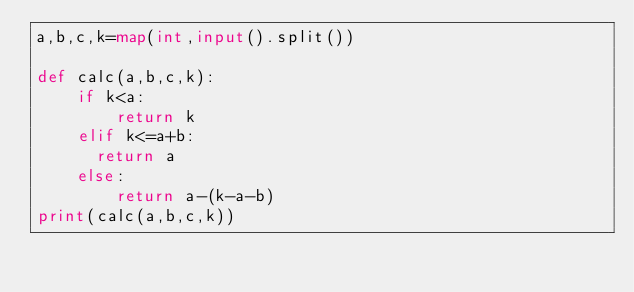Convert code to text. <code><loc_0><loc_0><loc_500><loc_500><_Python_>a,b,c,k=map(int,input().split())
 
def calc(a,b,c,k):
    if k<a:
        return k
    elif k<=a+b:
      return a
    else:
        return a-(k-a-b)
print(calc(a,b,c,k))</code> 